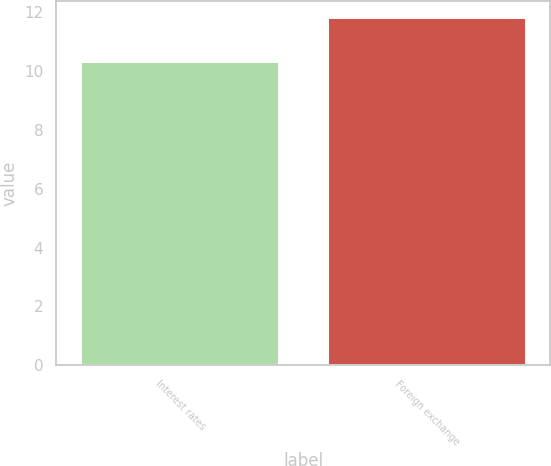Convert chart to OTSL. <chart><loc_0><loc_0><loc_500><loc_500><bar_chart><fcel>Interest rates<fcel>Foreign exchange<nl><fcel>10.3<fcel>11.8<nl></chart> 